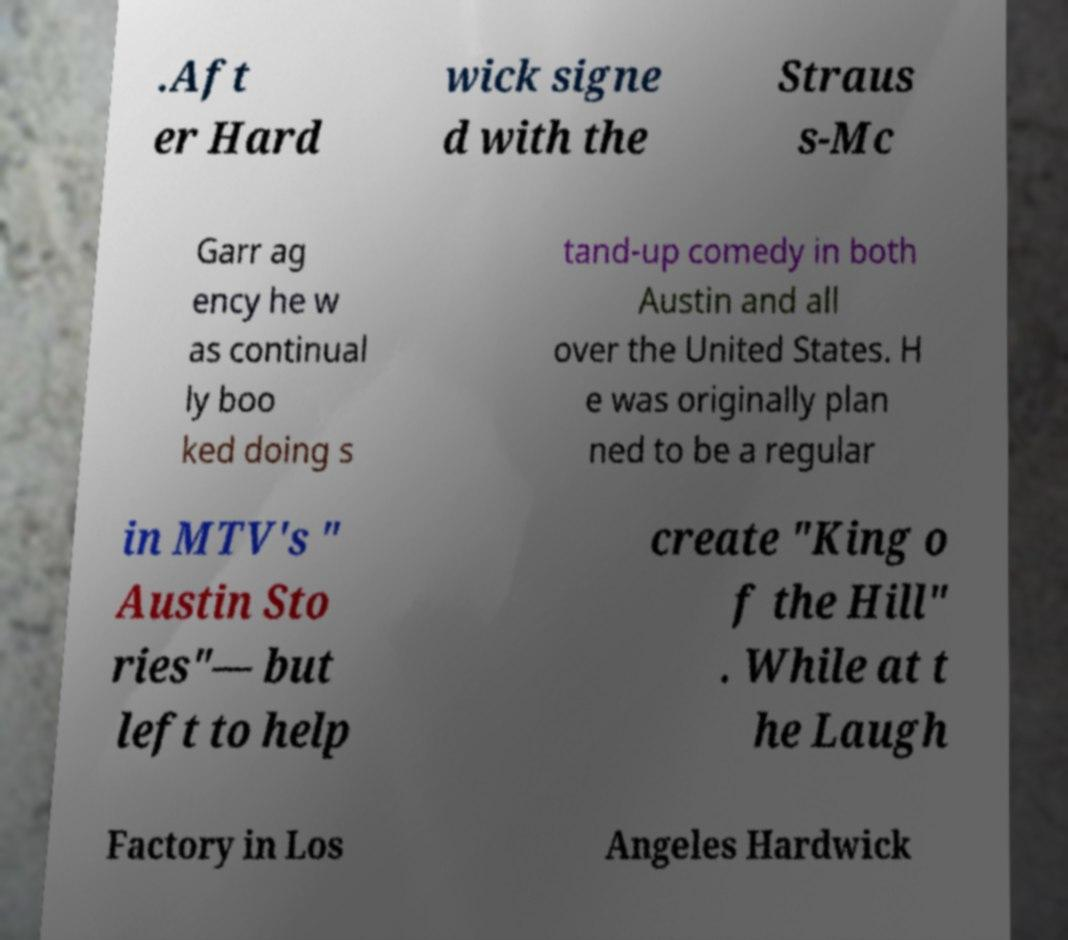For documentation purposes, I need the text within this image transcribed. Could you provide that? .Aft er Hard wick signe d with the Straus s-Mc Garr ag ency he w as continual ly boo ked doing s tand-up comedy in both Austin and all over the United States. H e was originally plan ned to be a regular in MTV's " Austin Sto ries"— but left to help create "King o f the Hill" . While at t he Laugh Factory in Los Angeles Hardwick 